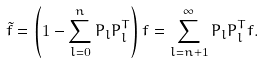Convert formula to latex. <formula><loc_0><loc_0><loc_500><loc_500>\tilde { f } = \left ( 1 - \sum _ { l = 0 } ^ { n } { P } _ { l } { P } _ { l } ^ { T } \right ) { f } = \sum _ { l = n + 1 } ^ { \infty } { P } _ { l } { P } _ { l } ^ { T } { f } .</formula> 